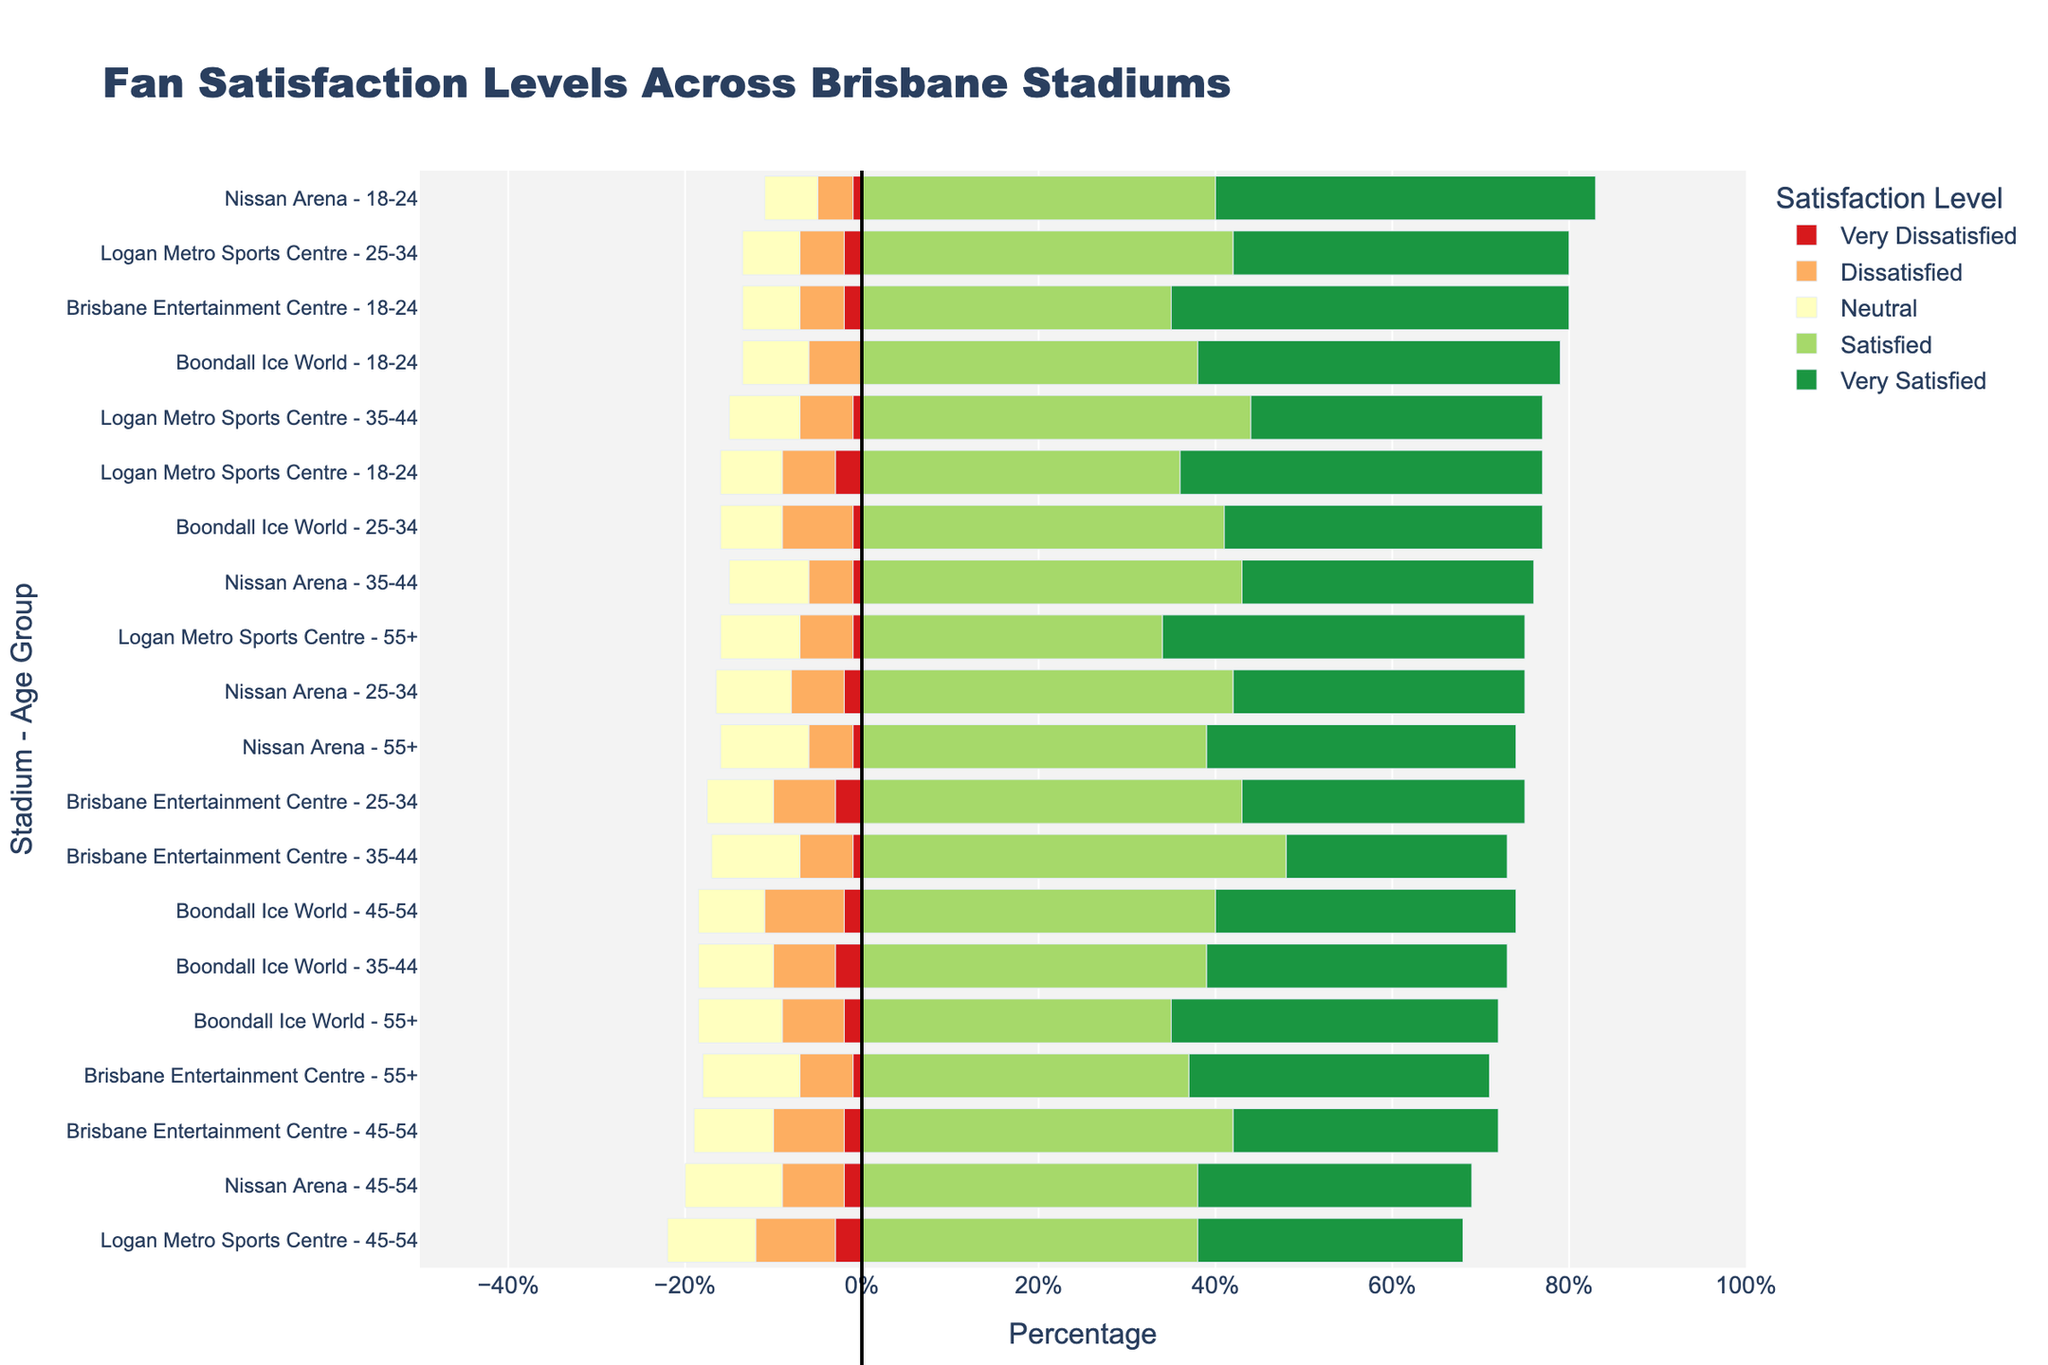Which age group at Brisbane Entertainment Centre had the highest percentage of "Satisfied" fans? First, locate Brisbane Entertainment Centre on the y-axis. Then, look for the "Satisfied" bar for each age group within this stadium. Measure the length of these bars to find the maximum.
Answer: 35-44 Which stadium had the highest percentage of "Very Dissatisfied" fans in the 25-34 age group? Look across the 25-34 age group entries for each stadium. Compare the lengths of the "Very Dissatisfied" bars to find the one with the highest percentage.
Answer: Brisbane Entertainment Centre Compare the percentage of "Neutral" fans in the 55+ age groups between Brisbane Entertainment Centre and Logan Metro Sports Centre. Which stadium had a higher percentage? For the 55+ age group, locate the "Neutral" bar at Brisbane Entertainment Centre and Logan Metro Sports Centre. Measure their lengths and compare them.
Answer: Brisbane Entertainment Centre What is the sum of the percentages for "Satisfied" and "Very Satisfied" fans aged 18-24 at Nissan Arena? At Nissan Arena, locate the 18-24 age group. Add the percentages of "Satisfied" and "Very Satisfied" fans: 40% + 43%.
Answer: 83% Which age group at Boondall Ice World had the lowest percentage of "Dissatisfied" fans? Focus on Boondall Ice World. Compare the "Dissatisfied" bars across all age groups to find the shortest one.
Answer: 18-24 How does the percentage of "Very Satisfied" fans aged 45-54 compare between Boondall Ice World and Logan Metro Sports Centre? Look at the "Very Satisfied" bars for the 45-54 age group in both stadiums. Compare their lengths to see which one is longer.
Answer: Logan Metro Sports Centre has a higher percentage Calculate the difference in the percentage of "Very Satisfied" fans in the 18-24 age group between Logan Metro Sports Centre and Brisbane Entertainment Centre. Identify the "Very Satisfied" bars for the 18-24 age group in both stadiums. Subtract Brisbane Entertainment Centre's value from Logan Metro Sports Centre's value (41% - 45%).
Answer: -4% Which stadium had the highest percentage of dissatisfied fans aged 35-44? Examine the "Dissatisfied" bars for the 35-44 age group across all stadiums. Identify the tallest bar to determine which has the highest percentage.
Answer: Brisbane Entertainment Centre Does Boondall Ice World or Nissan Arena have a higher percentage of neutral fans in the 25-34 age group? For the 25-34 age group, compare the "Neutral" bars at Boondall Ice World and Nissan Arena. Measure their lengths to see which is longer.
Answer: Boondall Ice World How does the overall satisfaction (combination of "Satisfied" and "Very Satisfied" percentages) for the 55+ age group compare between Nissan Arena and Logan Metro Sports Centre? For the 55+ age group, add the percentages of "Satisfied" and "Very Satisfied" fans at both Nissan Arena and Logan Metro Sports Centre. Nissan Arena: 39% + 35% = 74%. Logan Metro Sports Centre: 34% + 41% = 75%. Compare these sums.
Answer: Logan Metro Sports Centre has a higher overall satisfaction 